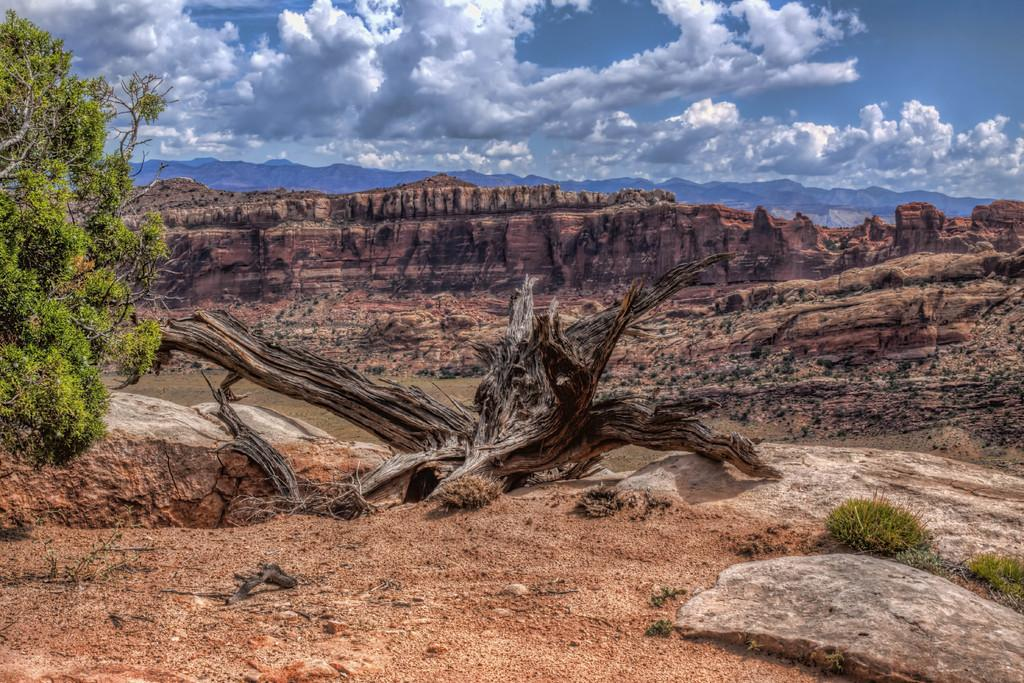What type of vegetation is present in the image? There is a tree and a plant in the image. What can be found on the ground in the image? There are objects on the ground in the image. What is visible in the background of the image? There are mountains and the sky in the background of the image. What type of afterthought is present in the image? There is no afterthought present in the image; it is a photograph of natural elements and does not contain any thoughts or ideas. 